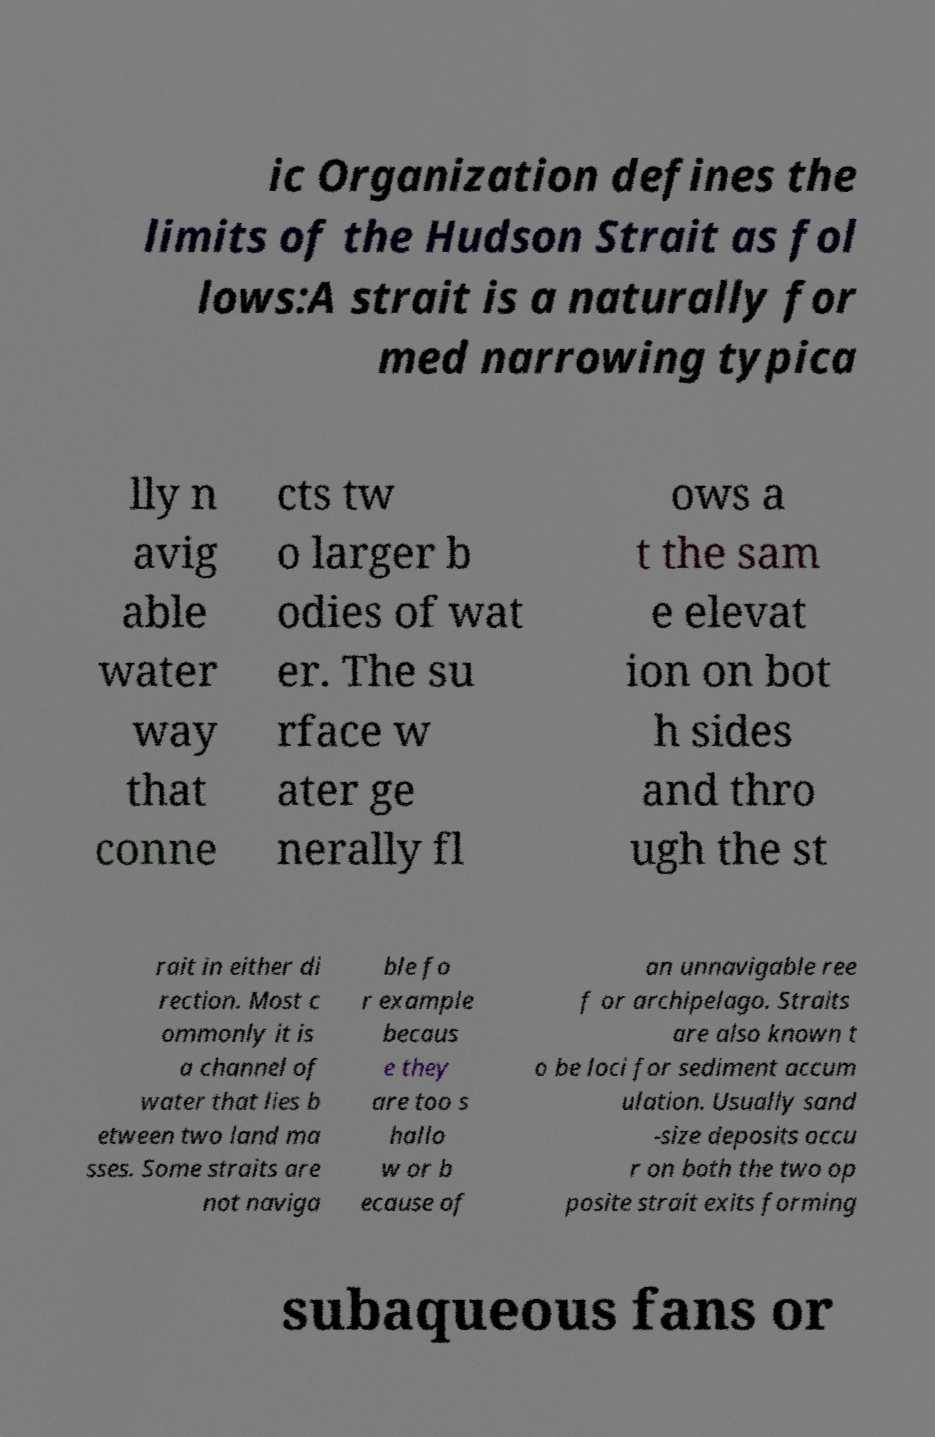Can you accurately transcribe the text from the provided image for me? ic Organization defines the limits of the Hudson Strait as fol lows:A strait is a naturally for med narrowing typica lly n avig able water way that conne cts tw o larger b odies of wat er. The su rface w ater ge nerally fl ows a t the sam e elevat ion on bot h sides and thro ugh the st rait in either di rection. Most c ommonly it is a channel of water that lies b etween two land ma sses. Some straits are not naviga ble fo r example becaus e they are too s hallo w or b ecause of an unnavigable ree f or archipelago. Straits are also known t o be loci for sediment accum ulation. Usually sand -size deposits occu r on both the two op posite strait exits forming subaqueous fans or 